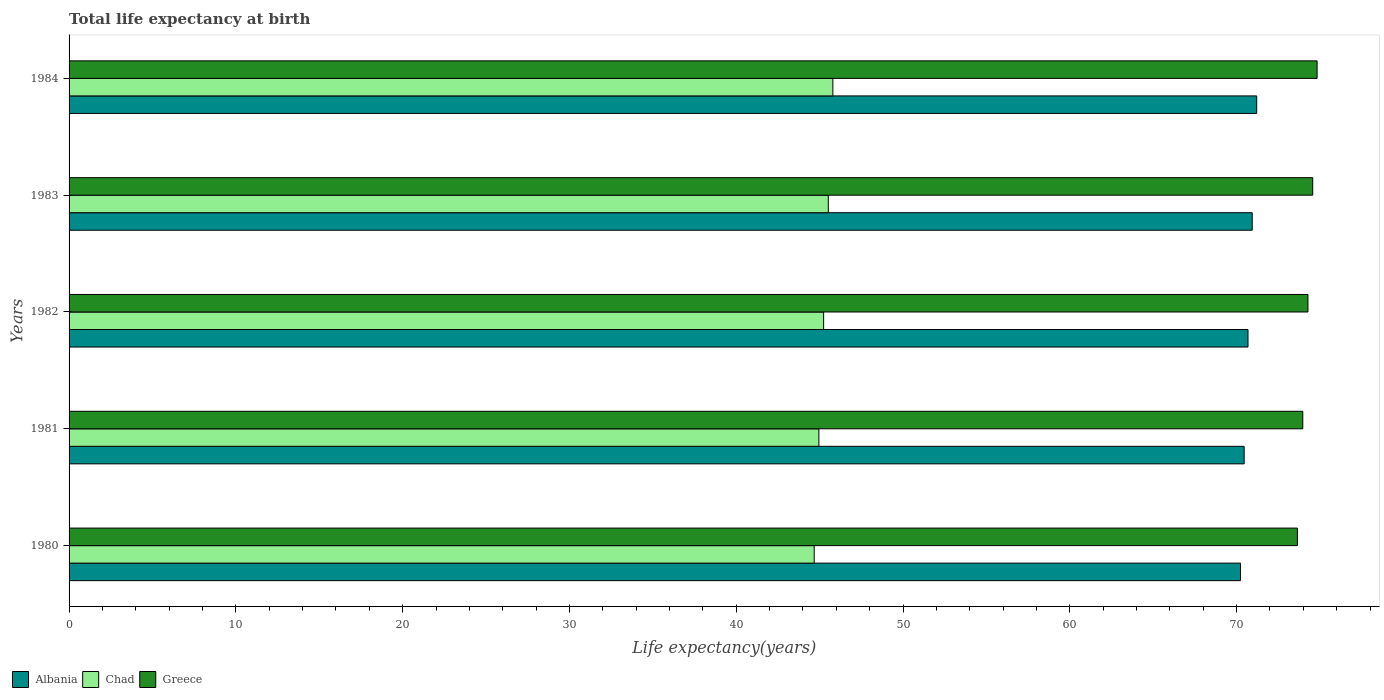How many different coloured bars are there?
Offer a terse response. 3. Are the number of bars per tick equal to the number of legend labels?
Give a very brief answer. Yes. Are the number of bars on each tick of the Y-axis equal?
Provide a succinct answer. Yes. How many bars are there on the 3rd tick from the top?
Give a very brief answer. 3. What is the label of the 3rd group of bars from the top?
Give a very brief answer. 1982. What is the life expectancy at birth in in Albania in 1984?
Your answer should be very brief. 71.21. Across all years, what is the maximum life expectancy at birth in in Albania?
Make the answer very short. 71.21. Across all years, what is the minimum life expectancy at birth in in Chad?
Provide a short and direct response. 44.67. In which year was the life expectancy at birth in in Albania minimum?
Ensure brevity in your answer.  1980. What is the total life expectancy at birth in in Greece in the graph?
Offer a very short reply. 371.29. What is the difference between the life expectancy at birth in in Chad in 1980 and that in 1983?
Offer a terse response. -0.85. What is the difference between the life expectancy at birth in in Chad in 1983 and the life expectancy at birth in in Greece in 1984?
Your answer should be very brief. -29.31. What is the average life expectancy at birth in in Greece per year?
Give a very brief answer. 74.26. In the year 1980, what is the difference between the life expectancy at birth in in Albania and life expectancy at birth in in Chad?
Give a very brief answer. 25.56. What is the ratio of the life expectancy at birth in in Albania in 1983 to that in 1984?
Make the answer very short. 1. What is the difference between the highest and the second highest life expectancy at birth in in Chad?
Keep it short and to the point. 0.27. What is the difference between the highest and the lowest life expectancy at birth in in Greece?
Your response must be concise. 1.18. Is the sum of the life expectancy at birth in in Greece in 1982 and 1983 greater than the maximum life expectancy at birth in in Albania across all years?
Provide a short and direct response. Yes. What does the 2nd bar from the bottom in 1980 represents?
Make the answer very short. Chad. Is it the case that in every year, the sum of the life expectancy at birth in in Albania and life expectancy at birth in in Chad is greater than the life expectancy at birth in in Greece?
Your answer should be very brief. Yes. How many bars are there?
Your answer should be very brief. 15. Does the graph contain any zero values?
Your answer should be very brief. No. Does the graph contain grids?
Offer a terse response. No. How many legend labels are there?
Keep it short and to the point. 3. What is the title of the graph?
Provide a succinct answer. Total life expectancy at birth. Does "Netherlands" appear as one of the legend labels in the graph?
Ensure brevity in your answer.  No. What is the label or title of the X-axis?
Make the answer very short. Life expectancy(years). What is the Life expectancy(years) in Albania in 1980?
Your answer should be compact. 70.24. What is the Life expectancy(years) of Chad in 1980?
Give a very brief answer. 44.67. What is the Life expectancy(years) of Greece in 1980?
Ensure brevity in your answer.  73.65. What is the Life expectancy(years) in Albania in 1981?
Make the answer very short. 70.45. What is the Life expectancy(years) in Chad in 1981?
Offer a very short reply. 44.96. What is the Life expectancy(years) in Greece in 1981?
Ensure brevity in your answer.  73.97. What is the Life expectancy(years) of Albania in 1982?
Your answer should be compact. 70.69. What is the Life expectancy(years) in Chad in 1982?
Offer a terse response. 45.24. What is the Life expectancy(years) in Greece in 1982?
Your response must be concise. 74.28. What is the Life expectancy(years) in Albania in 1983?
Keep it short and to the point. 70.94. What is the Life expectancy(years) of Chad in 1983?
Make the answer very short. 45.52. What is the Life expectancy(years) in Greece in 1983?
Your answer should be compact. 74.56. What is the Life expectancy(years) in Albania in 1984?
Provide a short and direct response. 71.21. What is the Life expectancy(years) in Chad in 1984?
Your answer should be compact. 45.79. What is the Life expectancy(years) in Greece in 1984?
Your answer should be very brief. 74.83. Across all years, what is the maximum Life expectancy(years) in Albania?
Your answer should be compact. 71.21. Across all years, what is the maximum Life expectancy(years) in Chad?
Give a very brief answer. 45.79. Across all years, what is the maximum Life expectancy(years) of Greece?
Your response must be concise. 74.83. Across all years, what is the minimum Life expectancy(years) in Albania?
Provide a succinct answer. 70.24. Across all years, what is the minimum Life expectancy(years) of Chad?
Provide a succinct answer. 44.67. Across all years, what is the minimum Life expectancy(years) of Greece?
Make the answer very short. 73.65. What is the total Life expectancy(years) in Albania in the graph?
Make the answer very short. 353.52. What is the total Life expectancy(years) of Chad in the graph?
Your response must be concise. 226.19. What is the total Life expectancy(years) of Greece in the graph?
Offer a terse response. 371.29. What is the difference between the Life expectancy(years) in Albania in 1980 and that in 1981?
Give a very brief answer. -0.22. What is the difference between the Life expectancy(years) of Chad in 1980 and that in 1981?
Your answer should be compact. -0.28. What is the difference between the Life expectancy(years) of Greece in 1980 and that in 1981?
Provide a succinct answer. -0.32. What is the difference between the Life expectancy(years) in Albania in 1980 and that in 1982?
Ensure brevity in your answer.  -0.45. What is the difference between the Life expectancy(years) in Chad in 1980 and that in 1982?
Give a very brief answer. -0.57. What is the difference between the Life expectancy(years) in Greece in 1980 and that in 1982?
Make the answer very short. -0.63. What is the difference between the Life expectancy(years) of Albania in 1980 and that in 1983?
Your answer should be compact. -0.7. What is the difference between the Life expectancy(years) of Chad in 1980 and that in 1983?
Make the answer very short. -0.85. What is the difference between the Life expectancy(years) in Greece in 1980 and that in 1983?
Make the answer very short. -0.92. What is the difference between the Life expectancy(years) of Albania in 1980 and that in 1984?
Your answer should be very brief. -0.97. What is the difference between the Life expectancy(years) of Chad in 1980 and that in 1984?
Your answer should be compact. -1.12. What is the difference between the Life expectancy(years) in Greece in 1980 and that in 1984?
Your answer should be very brief. -1.18. What is the difference between the Life expectancy(years) of Albania in 1981 and that in 1982?
Ensure brevity in your answer.  -0.23. What is the difference between the Life expectancy(years) in Chad in 1981 and that in 1982?
Give a very brief answer. -0.28. What is the difference between the Life expectancy(years) of Greece in 1981 and that in 1982?
Provide a short and direct response. -0.31. What is the difference between the Life expectancy(years) of Albania in 1981 and that in 1983?
Provide a succinct answer. -0.48. What is the difference between the Life expectancy(years) of Chad in 1981 and that in 1983?
Your answer should be very brief. -0.56. What is the difference between the Life expectancy(years) in Greece in 1981 and that in 1983?
Keep it short and to the point. -0.6. What is the difference between the Life expectancy(years) of Albania in 1981 and that in 1984?
Give a very brief answer. -0.75. What is the difference between the Life expectancy(years) of Chad in 1981 and that in 1984?
Keep it short and to the point. -0.84. What is the difference between the Life expectancy(years) in Greece in 1981 and that in 1984?
Provide a succinct answer. -0.86. What is the difference between the Life expectancy(years) in Albania in 1982 and that in 1983?
Your answer should be very brief. -0.25. What is the difference between the Life expectancy(years) of Chad in 1982 and that in 1983?
Your answer should be compact. -0.28. What is the difference between the Life expectancy(years) of Greece in 1982 and that in 1983?
Provide a succinct answer. -0.29. What is the difference between the Life expectancy(years) in Albania in 1982 and that in 1984?
Give a very brief answer. -0.52. What is the difference between the Life expectancy(years) in Chad in 1982 and that in 1984?
Offer a very short reply. -0.55. What is the difference between the Life expectancy(years) in Greece in 1982 and that in 1984?
Give a very brief answer. -0.55. What is the difference between the Life expectancy(years) in Albania in 1983 and that in 1984?
Provide a short and direct response. -0.27. What is the difference between the Life expectancy(years) in Chad in 1983 and that in 1984?
Provide a short and direct response. -0.27. What is the difference between the Life expectancy(years) of Greece in 1983 and that in 1984?
Your response must be concise. -0.26. What is the difference between the Life expectancy(years) of Albania in 1980 and the Life expectancy(years) of Chad in 1981?
Your response must be concise. 25.28. What is the difference between the Life expectancy(years) of Albania in 1980 and the Life expectancy(years) of Greece in 1981?
Your response must be concise. -3.73. What is the difference between the Life expectancy(years) in Chad in 1980 and the Life expectancy(years) in Greece in 1981?
Your response must be concise. -29.29. What is the difference between the Life expectancy(years) in Albania in 1980 and the Life expectancy(years) in Chad in 1982?
Ensure brevity in your answer.  25. What is the difference between the Life expectancy(years) in Albania in 1980 and the Life expectancy(years) in Greece in 1982?
Your response must be concise. -4.04. What is the difference between the Life expectancy(years) of Chad in 1980 and the Life expectancy(years) of Greece in 1982?
Your answer should be very brief. -29.6. What is the difference between the Life expectancy(years) in Albania in 1980 and the Life expectancy(years) in Chad in 1983?
Keep it short and to the point. 24.71. What is the difference between the Life expectancy(years) of Albania in 1980 and the Life expectancy(years) of Greece in 1983?
Keep it short and to the point. -4.33. What is the difference between the Life expectancy(years) in Chad in 1980 and the Life expectancy(years) in Greece in 1983?
Your answer should be very brief. -29.89. What is the difference between the Life expectancy(years) of Albania in 1980 and the Life expectancy(years) of Chad in 1984?
Ensure brevity in your answer.  24.44. What is the difference between the Life expectancy(years) of Albania in 1980 and the Life expectancy(years) of Greece in 1984?
Provide a succinct answer. -4.59. What is the difference between the Life expectancy(years) in Chad in 1980 and the Life expectancy(years) in Greece in 1984?
Offer a very short reply. -30.15. What is the difference between the Life expectancy(years) of Albania in 1981 and the Life expectancy(years) of Chad in 1982?
Provide a succinct answer. 25.21. What is the difference between the Life expectancy(years) in Albania in 1981 and the Life expectancy(years) in Greece in 1982?
Your answer should be compact. -3.82. What is the difference between the Life expectancy(years) of Chad in 1981 and the Life expectancy(years) of Greece in 1982?
Provide a succinct answer. -29.32. What is the difference between the Life expectancy(years) of Albania in 1981 and the Life expectancy(years) of Chad in 1983?
Offer a very short reply. 24.93. What is the difference between the Life expectancy(years) in Albania in 1981 and the Life expectancy(years) in Greece in 1983?
Make the answer very short. -4.11. What is the difference between the Life expectancy(years) of Chad in 1981 and the Life expectancy(years) of Greece in 1983?
Your response must be concise. -29.61. What is the difference between the Life expectancy(years) in Albania in 1981 and the Life expectancy(years) in Chad in 1984?
Your response must be concise. 24.66. What is the difference between the Life expectancy(years) in Albania in 1981 and the Life expectancy(years) in Greece in 1984?
Make the answer very short. -4.37. What is the difference between the Life expectancy(years) in Chad in 1981 and the Life expectancy(years) in Greece in 1984?
Give a very brief answer. -29.87. What is the difference between the Life expectancy(years) in Albania in 1982 and the Life expectancy(years) in Chad in 1983?
Your answer should be very brief. 25.16. What is the difference between the Life expectancy(years) in Albania in 1982 and the Life expectancy(years) in Greece in 1983?
Make the answer very short. -3.88. What is the difference between the Life expectancy(years) in Chad in 1982 and the Life expectancy(years) in Greece in 1983?
Your response must be concise. -29.32. What is the difference between the Life expectancy(years) in Albania in 1982 and the Life expectancy(years) in Chad in 1984?
Keep it short and to the point. 24.89. What is the difference between the Life expectancy(years) in Albania in 1982 and the Life expectancy(years) in Greece in 1984?
Keep it short and to the point. -4.14. What is the difference between the Life expectancy(years) in Chad in 1982 and the Life expectancy(years) in Greece in 1984?
Keep it short and to the point. -29.59. What is the difference between the Life expectancy(years) of Albania in 1983 and the Life expectancy(years) of Chad in 1984?
Offer a very short reply. 25.14. What is the difference between the Life expectancy(years) of Albania in 1983 and the Life expectancy(years) of Greece in 1984?
Ensure brevity in your answer.  -3.89. What is the difference between the Life expectancy(years) of Chad in 1983 and the Life expectancy(years) of Greece in 1984?
Give a very brief answer. -29.31. What is the average Life expectancy(years) in Albania per year?
Make the answer very short. 70.7. What is the average Life expectancy(years) of Chad per year?
Offer a terse response. 45.24. What is the average Life expectancy(years) in Greece per year?
Keep it short and to the point. 74.26. In the year 1980, what is the difference between the Life expectancy(years) in Albania and Life expectancy(years) in Chad?
Provide a succinct answer. 25.56. In the year 1980, what is the difference between the Life expectancy(years) of Albania and Life expectancy(years) of Greece?
Offer a very short reply. -3.41. In the year 1980, what is the difference between the Life expectancy(years) of Chad and Life expectancy(years) of Greece?
Provide a succinct answer. -28.97. In the year 1981, what is the difference between the Life expectancy(years) in Albania and Life expectancy(years) in Chad?
Offer a very short reply. 25.5. In the year 1981, what is the difference between the Life expectancy(years) of Albania and Life expectancy(years) of Greece?
Make the answer very short. -3.52. In the year 1981, what is the difference between the Life expectancy(years) in Chad and Life expectancy(years) in Greece?
Offer a very short reply. -29.01. In the year 1982, what is the difference between the Life expectancy(years) in Albania and Life expectancy(years) in Chad?
Offer a terse response. 25.44. In the year 1982, what is the difference between the Life expectancy(years) in Albania and Life expectancy(years) in Greece?
Offer a very short reply. -3.59. In the year 1982, what is the difference between the Life expectancy(years) in Chad and Life expectancy(years) in Greece?
Provide a succinct answer. -29.04. In the year 1983, what is the difference between the Life expectancy(years) in Albania and Life expectancy(years) in Chad?
Ensure brevity in your answer.  25.42. In the year 1983, what is the difference between the Life expectancy(years) in Albania and Life expectancy(years) in Greece?
Ensure brevity in your answer.  -3.63. In the year 1983, what is the difference between the Life expectancy(years) of Chad and Life expectancy(years) of Greece?
Your answer should be compact. -29.04. In the year 1984, what is the difference between the Life expectancy(years) of Albania and Life expectancy(years) of Chad?
Offer a terse response. 25.41. In the year 1984, what is the difference between the Life expectancy(years) in Albania and Life expectancy(years) in Greece?
Ensure brevity in your answer.  -3.62. In the year 1984, what is the difference between the Life expectancy(years) in Chad and Life expectancy(years) in Greece?
Your answer should be very brief. -29.03. What is the ratio of the Life expectancy(years) in Albania in 1980 to that in 1981?
Provide a short and direct response. 1. What is the ratio of the Life expectancy(years) of Chad in 1980 to that in 1982?
Your response must be concise. 0.99. What is the ratio of the Life expectancy(years) in Greece in 1980 to that in 1982?
Provide a short and direct response. 0.99. What is the ratio of the Life expectancy(years) of Albania in 1980 to that in 1983?
Offer a terse response. 0.99. What is the ratio of the Life expectancy(years) of Chad in 1980 to that in 1983?
Offer a very short reply. 0.98. What is the ratio of the Life expectancy(years) of Greece in 1980 to that in 1983?
Ensure brevity in your answer.  0.99. What is the ratio of the Life expectancy(years) of Albania in 1980 to that in 1984?
Provide a short and direct response. 0.99. What is the ratio of the Life expectancy(years) of Chad in 1980 to that in 1984?
Give a very brief answer. 0.98. What is the ratio of the Life expectancy(years) in Greece in 1980 to that in 1984?
Offer a very short reply. 0.98. What is the ratio of the Life expectancy(years) of Albania in 1981 to that in 1983?
Keep it short and to the point. 0.99. What is the ratio of the Life expectancy(years) in Chad in 1981 to that in 1983?
Your answer should be very brief. 0.99. What is the ratio of the Life expectancy(years) in Albania in 1981 to that in 1984?
Provide a succinct answer. 0.99. What is the ratio of the Life expectancy(years) in Chad in 1981 to that in 1984?
Offer a very short reply. 0.98. What is the ratio of the Life expectancy(years) of Chad in 1982 to that in 1983?
Offer a very short reply. 0.99. What is the ratio of the Life expectancy(years) of Chad in 1982 to that in 1984?
Give a very brief answer. 0.99. What is the ratio of the Life expectancy(years) in Chad in 1983 to that in 1984?
Make the answer very short. 0.99. What is the ratio of the Life expectancy(years) in Greece in 1983 to that in 1984?
Your response must be concise. 1. What is the difference between the highest and the second highest Life expectancy(years) of Albania?
Offer a terse response. 0.27. What is the difference between the highest and the second highest Life expectancy(years) of Chad?
Provide a short and direct response. 0.27. What is the difference between the highest and the second highest Life expectancy(years) of Greece?
Your answer should be compact. 0.26. What is the difference between the highest and the lowest Life expectancy(years) of Albania?
Your response must be concise. 0.97. What is the difference between the highest and the lowest Life expectancy(years) in Chad?
Offer a very short reply. 1.12. What is the difference between the highest and the lowest Life expectancy(years) of Greece?
Ensure brevity in your answer.  1.18. 